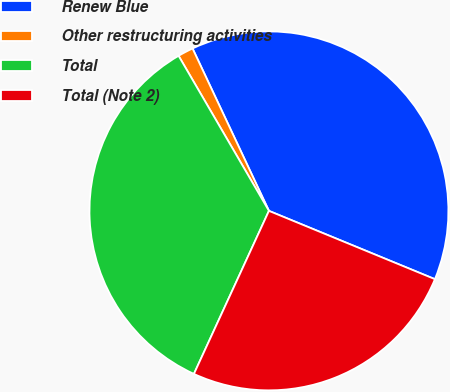<chart> <loc_0><loc_0><loc_500><loc_500><pie_chart><fcel>Renew Blue<fcel>Other restructuring activities<fcel>Total<fcel>Total (Note 2)<nl><fcel>38.21%<fcel>1.4%<fcel>34.74%<fcel>25.65%<nl></chart> 